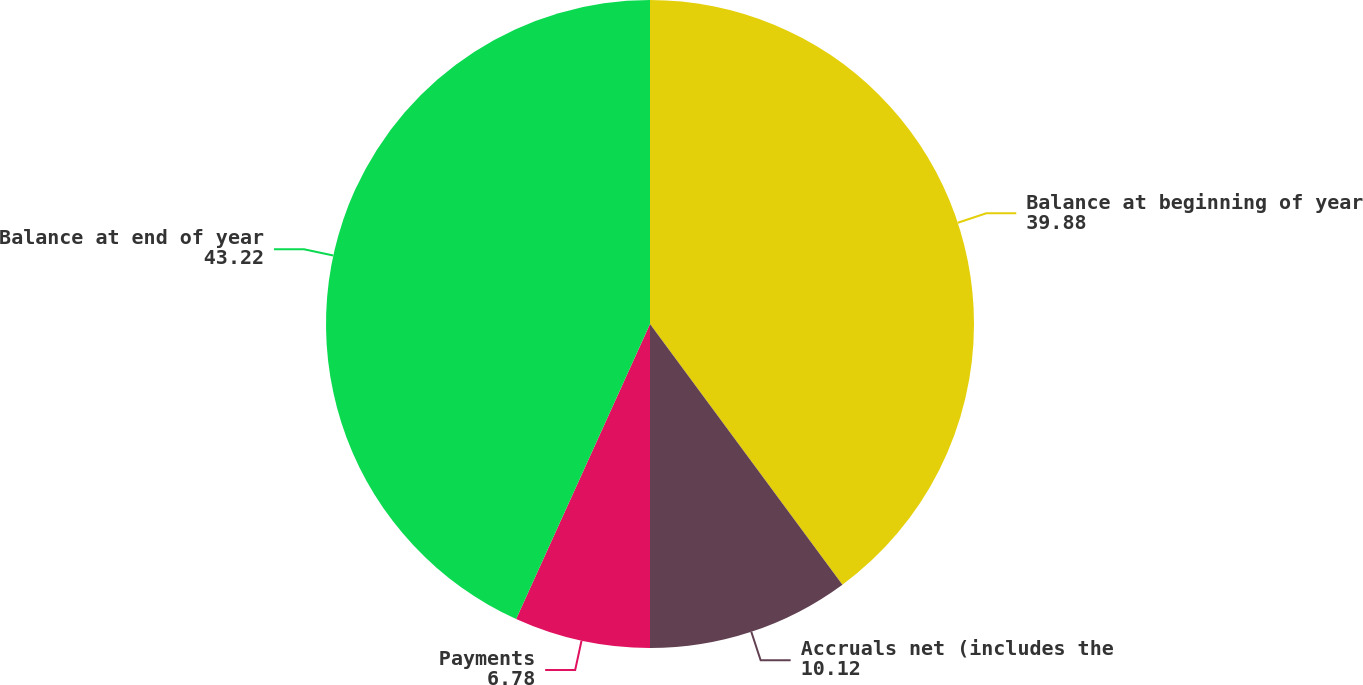<chart> <loc_0><loc_0><loc_500><loc_500><pie_chart><fcel>Balance at beginning of year<fcel>Accruals net (includes the<fcel>Payments<fcel>Balance at end of year<nl><fcel>39.88%<fcel>10.12%<fcel>6.78%<fcel>43.22%<nl></chart> 